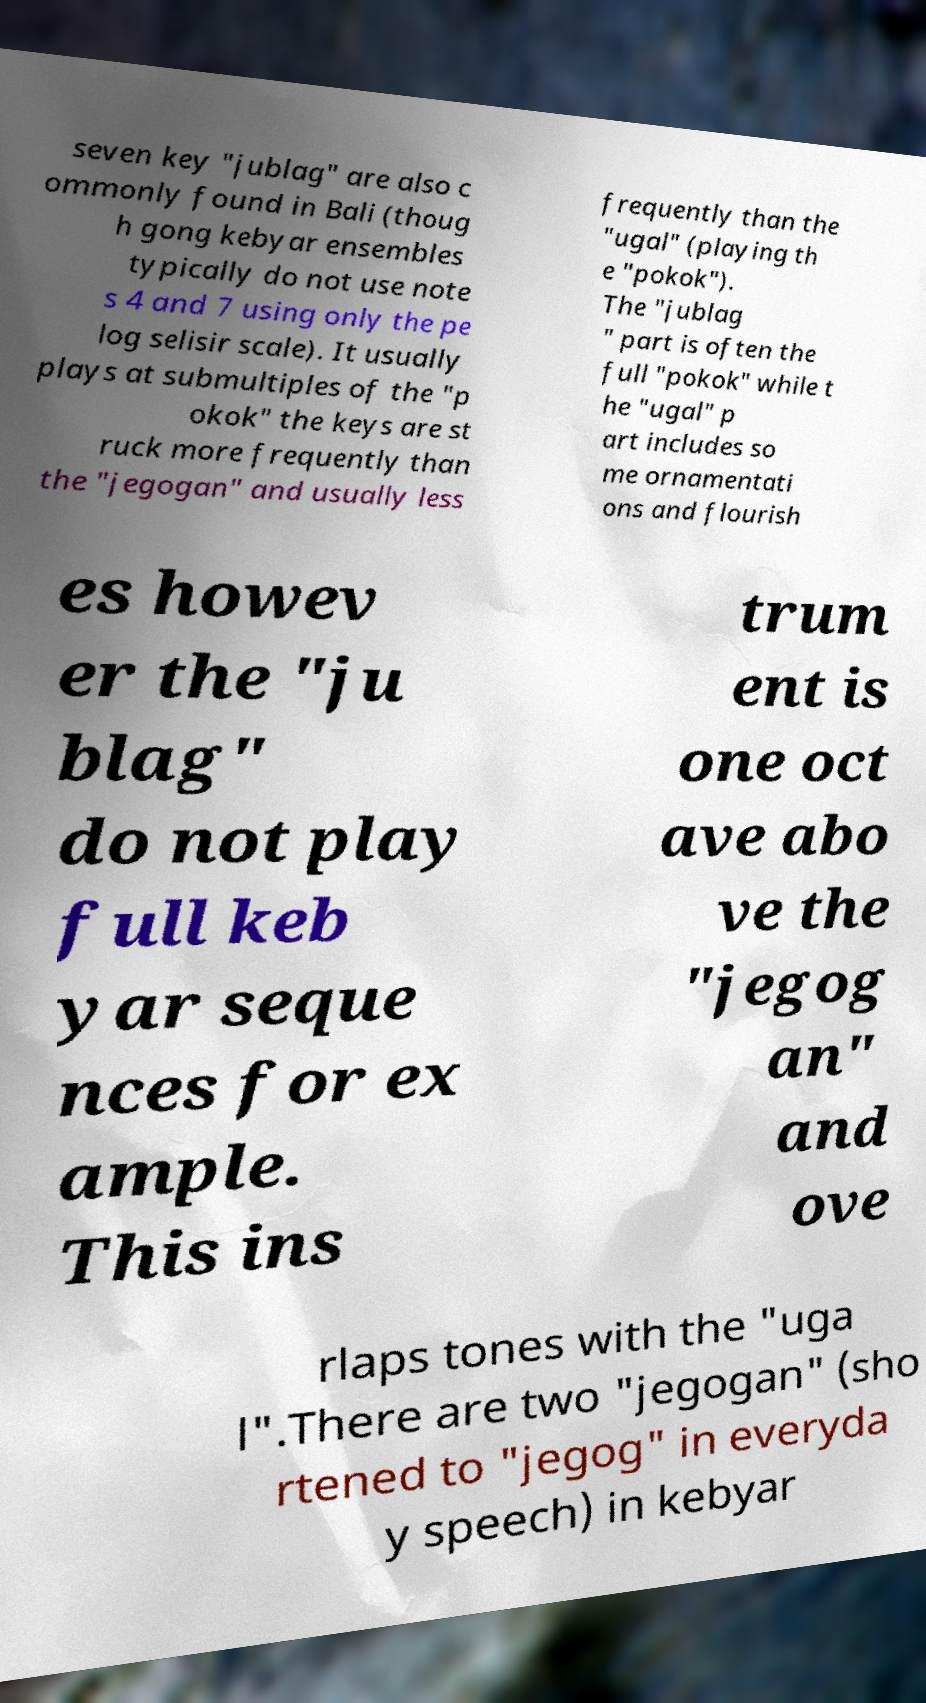Please read and relay the text visible in this image. What does it say? seven key "jublag" are also c ommonly found in Bali (thoug h gong kebyar ensembles typically do not use note s 4 and 7 using only the pe log selisir scale). It usually plays at submultiples of the "p okok" the keys are st ruck more frequently than the "jegogan" and usually less frequently than the "ugal" (playing th e "pokok"). The "jublag " part is often the full "pokok" while t he "ugal" p art includes so me ornamentati ons and flourish es howev er the "ju blag" do not play full keb yar seque nces for ex ample. This ins trum ent is one oct ave abo ve the "jegog an" and ove rlaps tones with the "uga l".There are two "jegogan" (sho rtened to "jegog" in everyda y speech) in kebyar 